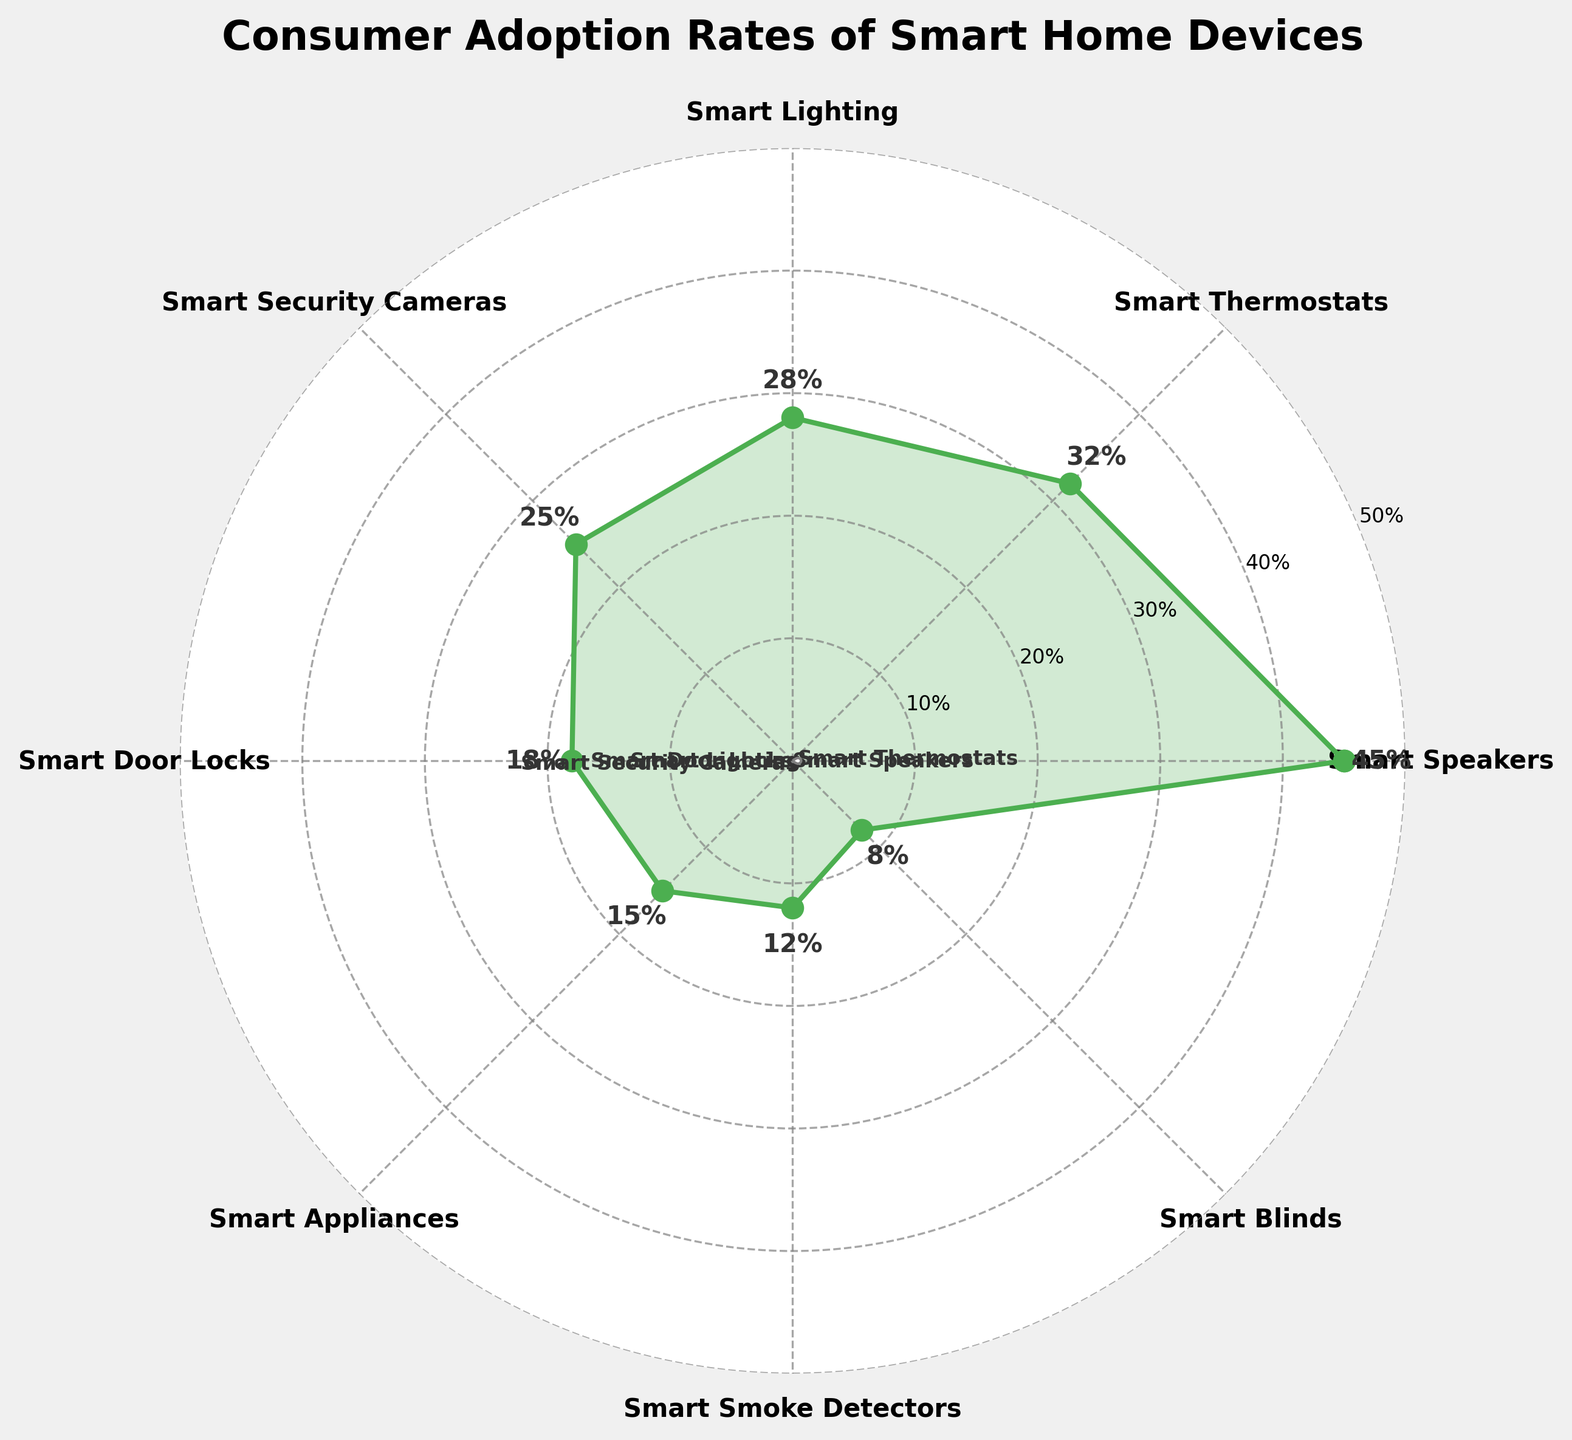Which category has the highest adoption rate? By looking at the highest data point in the plot, you can identify that Smart Speakers have the highest value.
Answer: Smart Speakers What is the adoption rate of Smart Door Locks? Locate the data point for Smart Door Locks in the plot; the connected marker will have the adoption rate labeled.
Answer: 18% Which smart home device has the lowest adoption rate? Identify the data point with the lowest value on the plot; this corresponds to Smart Blinds.
Answer: Smart Blinds How many categories have an adoption rate of 20% or higher? Count the number of data points that are at 20% or higher; these are Smart Speakers, Smart Thermostats, Smart Lighting, and Smart Security Cameras.
Answer: 4 What is the difference in adoption rate between Smart Lighting and Smart Security Cameras? Look at the data points for both categories: Smart Lighting (28%) and Smart Security Cameras (25%). Subtract the smaller value from the larger one.
Answer: 3% What is the average adoption rate of Smart Smoke Detectors and Smart Appliances? Sum the adoption rates for both categories: Smart Smoke Detectors (12%) and Smart Appliances (15%) and then divide by 2. (12 + 15) / 2 = 13.5
Answer: 13.5% Which category has a higher adoption rate: Smart Thermostats or Smart Door Locks? Compare the adoption rates of Smart Thermostats (32%) and Smart Door Locks (18%) by observing the plot.
Answer: Smart Thermostats What is the total adoption rate of Smart Speakers, Smart Lighting, and Smart Blinds combined? Sum the adoption rates for these categories: 45% (Smart Speakers) + 28% (Smart Lighting) + 8% (Smart Blinds). 45 + 28 + 8 = 81
Answer: 81% What is the most common range of adoption rates visible on the plot (e.g., 0-10%, 10-20%, etc.)? Count the number of data points within each range: 
- 0-10%: 1 (Smart Blinds)
- 10-20%: 3 (Smart Smoke Detectors, Smart Appliances, Smart Door Locks)
- 20-30%: 2 (Smart Security Cameras, Smart Lighting)
- 30-40%: 1 (Smart Thermostats)
- 40-50%: 1 (Smart Speakers)
The most common is 10-20%
Answer: 10-20% Are there more devices with adoption rates above or below 20%? Count the data points:
- Above 20%: 4 (Smart Speakers, Smart Thermostats, Smart Lighting, and Smart Security Cameras)
- Below 20%: 4 (Smart Door Locks, Smart Appliances, Smart Smoke Detectors, Smart Blinds)
The numbers are equal
Answer: Equal 